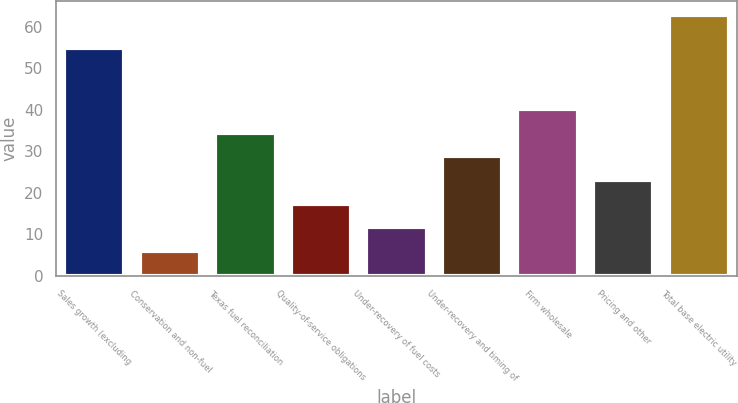<chart> <loc_0><loc_0><loc_500><loc_500><bar_chart><fcel>Sales growth (excluding<fcel>Conservation and non-fuel<fcel>Texas fuel reconciliation<fcel>Quality-of-service obligations<fcel>Under-recovery of fuel costs<fcel>Under-recovery and timing of<fcel>Firm wholesale<fcel>Pricing and other<fcel>Total base electric utility<nl><fcel>55<fcel>6<fcel>34.5<fcel>17.4<fcel>11.7<fcel>28.8<fcel>40.2<fcel>23.1<fcel>63<nl></chart> 